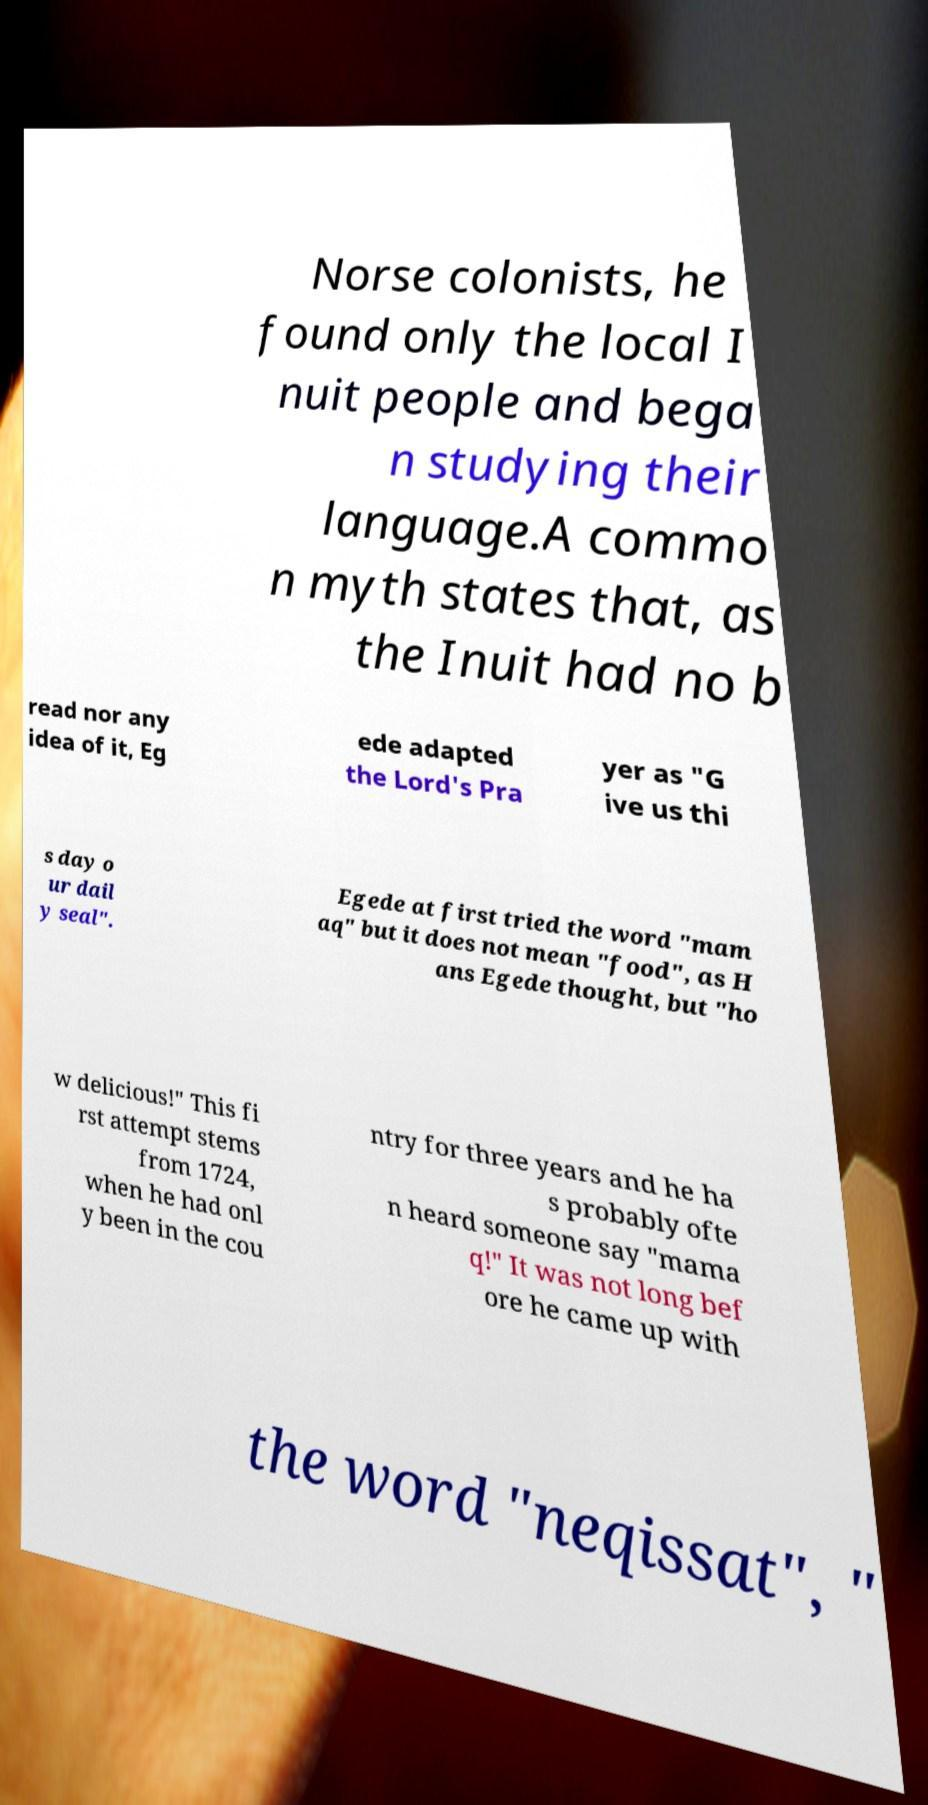Could you assist in decoding the text presented in this image and type it out clearly? Norse colonists, he found only the local I nuit people and bega n studying their language.A commo n myth states that, as the Inuit had no b read nor any idea of it, Eg ede adapted the Lord's Pra yer as "G ive us thi s day o ur dail y seal". Egede at first tried the word "mam aq" but it does not mean "food", as H ans Egede thought, but "ho w delicious!" This fi rst attempt stems from 1724, when he had onl y been in the cou ntry for three years and he ha s probably ofte n heard someone say "mama q!" It was not long bef ore he came up with the word "neqissat", " 